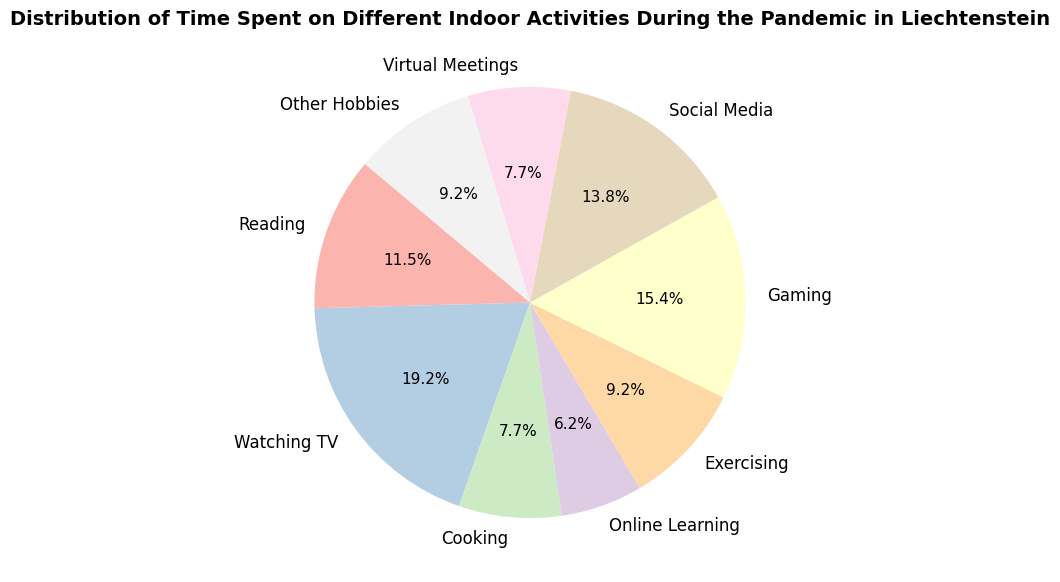What indoor activity took up the most time during the pandemic in Liechtenstein? The slice representing "Watching TV" is the largest among all slices, indicating it takes up the most time percentage-wise.
Answer: Watching TV How much time in total was spent on "Reading" and "Cooking"? The time spent on "Reading" is 15 hours and on "Cooking" is 10 hours. Adding these together, 15 + 10 = 25 hours.
Answer: 25 hours Which activity took up less time: "Exercising" or "Virtual Meetings"? "Exercising" has a slice representing 12 hours, while "Virtual Meetings" is shown with 10 hours. Since 10 < 12, "Virtual Meetings" took up less time.
Answer: Virtual Meetings How many activities took up at least 10 hours? According to the data, the activities that took up at least 10 hours are "Reading" (15), "Watching TV" (25), "Cooking" (10), "Gaming" (20), "Social Media" (18), "Virtual Meetings" (10), and "Other Hobbies" (12). Counting these up, 7 activities took at least 10 hours.
Answer: 7 activities What percentage of the total time was spent on "Gaming"? The total time across all activities is 130 hours (sum of all time spent values). The time spent on "Gaming" is 20 hours. Calculating the percentage: (20/130) * 100 ≈ 15.4%.
Answer: 15.4% Is more time spent on "Social Media" than on "Exercising"? The slice for "Social Media" represents 18 hours, and "Exercising" represents 12 hours. Since 18 > 12, more time was spent on "Social Media" than "Exercising".
Answer: Yes Which two activities combined make up the largest portion of the time spent? "Watching TV" (25 hours) and "Gaming" (20 hours) combined is 45 hours. Checking all other combinations, this is the largest sum.
Answer: Watching TV and Gaming What is the total time spent on non-digital activities? (hint: consider Reading, Cooking, Exercising, Other Hobbies) Adding up the hours spent on "Reading" (15), "Cooking" (10), "Exercising" (12), and "Other Hobbies" (12) results in 15 + 10 + 12 + 12 = 49 hours.
Answer: 49 hours 